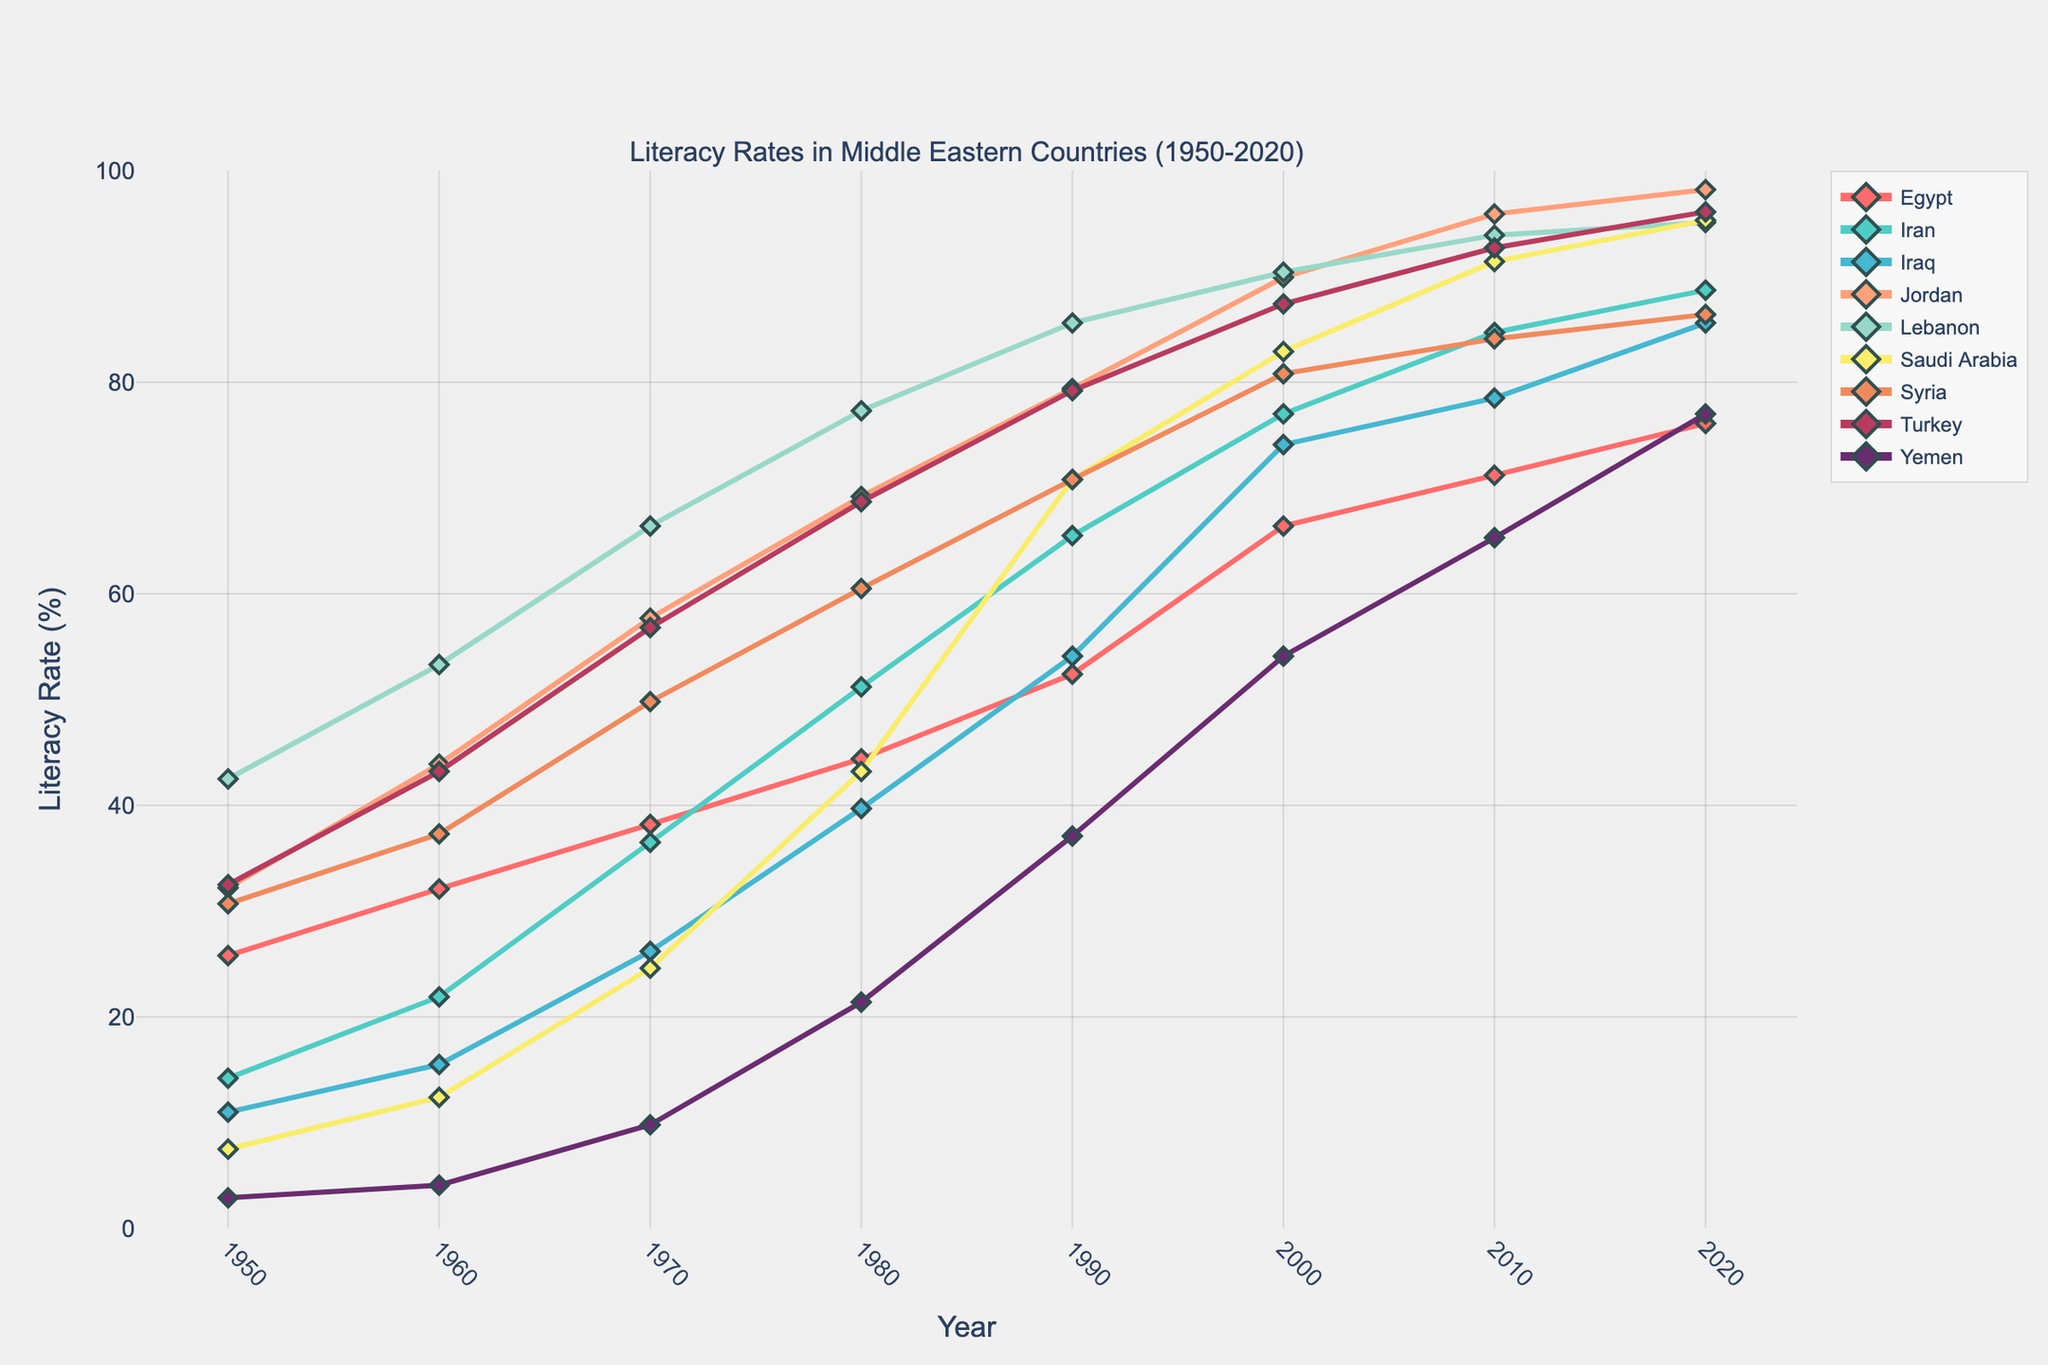Which country had the highest literacy rate in 2020? Look at the literacy rates in 2020 for all countries and find the highest value. Jordan has 98.2%, which is the highest.
Answer: Jordan Which two countries had the smallest increase in literacy rates from 1950 to 2020? Calculate the difference in literacy rates between 1950 and 2020 for each country. The smallest increases are for Lebanon (95.1 - 42.5 = 52.6) and Egypt (76.1 - 25.8 = 50.3).
Answer: Lebanon and Egypt Compare the literacy rate of Jordan and Iraq in 1980. Which country had a higher rate? In 1980, Jordan had a literacy rate of 69.2% while Iraq had 39.7%. Since 69.2% is greater than 39.7%, Jordan had a higher rate in 1980.
Answer: Jordan What is the average literacy rate for Turkey and Lebanon in the year 2000? Add the literacy rates of Turkey and Lebanon in 2000 and divide by 2: (87.4 + 90.4) / 2 = 88.9.
Answer: 88.9 In which decade did Saudi Arabia see the most significant increase in literacy rate? Find the differences in literacy rates for Saudi Arabia across each decade and identify the largest change: 1980-1990 has the greatest increase (70.8 - 43.2 = 27.6).
Answer: 1980-1990 Which country had the lowest literacy rate in 1950? Look at the literacy rates for 1950 and identify the lowest value. Yemen has the lowest value at 2.9%.
Answer: Yemen By how much did the literacy rate in Yemen increase from 1990 to 2020? Subtract the literacy rate of Yemen in 1990 from the rate in 2020: 77.0 - 37.1 = 39.9.
Answer: 39.9% Which countries had a literacy rate above 90% in 2010? Check the literacy rates for 2010 and identify which countries have rates above 90%. The countries are Jordan, Lebanon, Saudi Arabia, and Turkey.
Answer: Jordan, Lebanon, Saudi Arabia, Turkey Compare the literacy rates of Egypt and Iran in 2000. Which country had a higher rate and by how much? Iran had 77.0% and Egypt had 66.4% in 2000. The difference is 77.0 - 66.4 = 10.6. Iran had a higher rate by 10.6%.
Answer: Iran, 10.6% What visual pattern can you observe in the trends of literacy rates for all countries from 1950 to 2020? Observing the figure, all the countries show an upward trend in literacy rates from 1950 to 2020. This indicates a general improvement in literacy over time.
Answer: Upward trend for all countries 